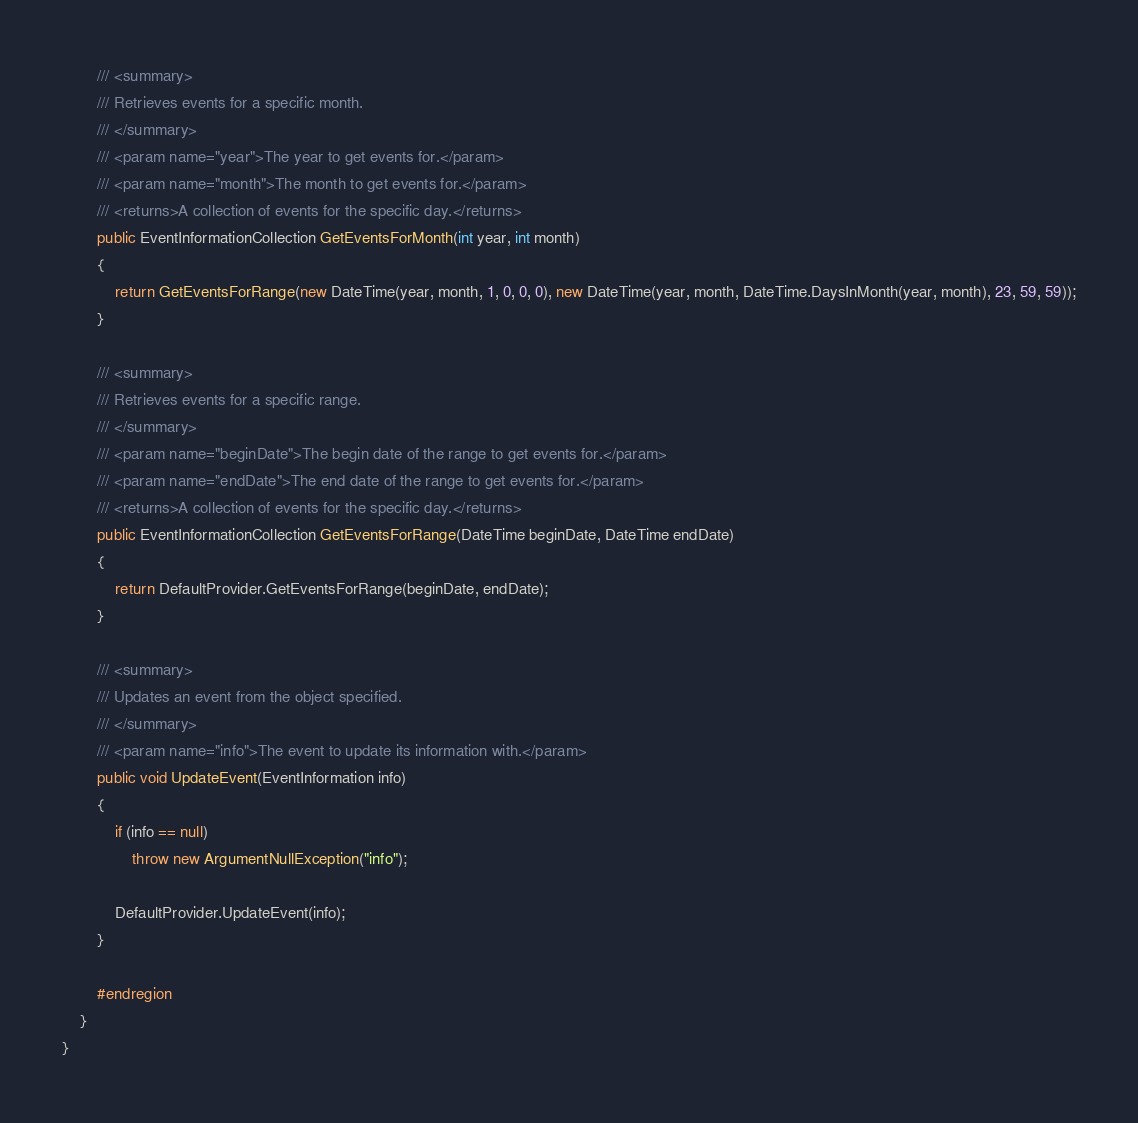Convert code to text. <code><loc_0><loc_0><loc_500><loc_500><_C#_>
		/// <summary>
		/// Retrieves events for a specific month.
		/// </summary>
		/// <param name="year">The year to get events for.</param>
		/// <param name="month">The month to get events for.</param>
		/// <returns>A collection of events for the specific day.</returns>
		public EventInformationCollection GetEventsForMonth(int year, int month)
		{
			return GetEventsForRange(new DateTime(year, month, 1, 0, 0, 0), new DateTime(year, month, DateTime.DaysInMonth(year, month), 23, 59, 59));
		}

		/// <summary>
		/// Retrieves events for a specific range.
		/// </summary>
		/// <param name="beginDate">The begin date of the range to get events for.</param>
		/// <param name="endDate">The end date of the range to get events for.</param>
		/// <returns>A collection of events for the specific day.</returns>
		public EventInformationCollection GetEventsForRange(DateTime beginDate, DateTime endDate)
		{
			return DefaultProvider.GetEventsForRange(beginDate, endDate);
		}

		/// <summary>
		/// Updates an event from the object specified.
		/// </summary>
		/// <param name="info">The event to update its information with.</param>
		public void UpdateEvent(EventInformation info)
		{
			if (info == null)
				throw new ArgumentNullException("info");

			DefaultProvider.UpdateEvent(info);
		}

		#endregion
	}
}
</code> 